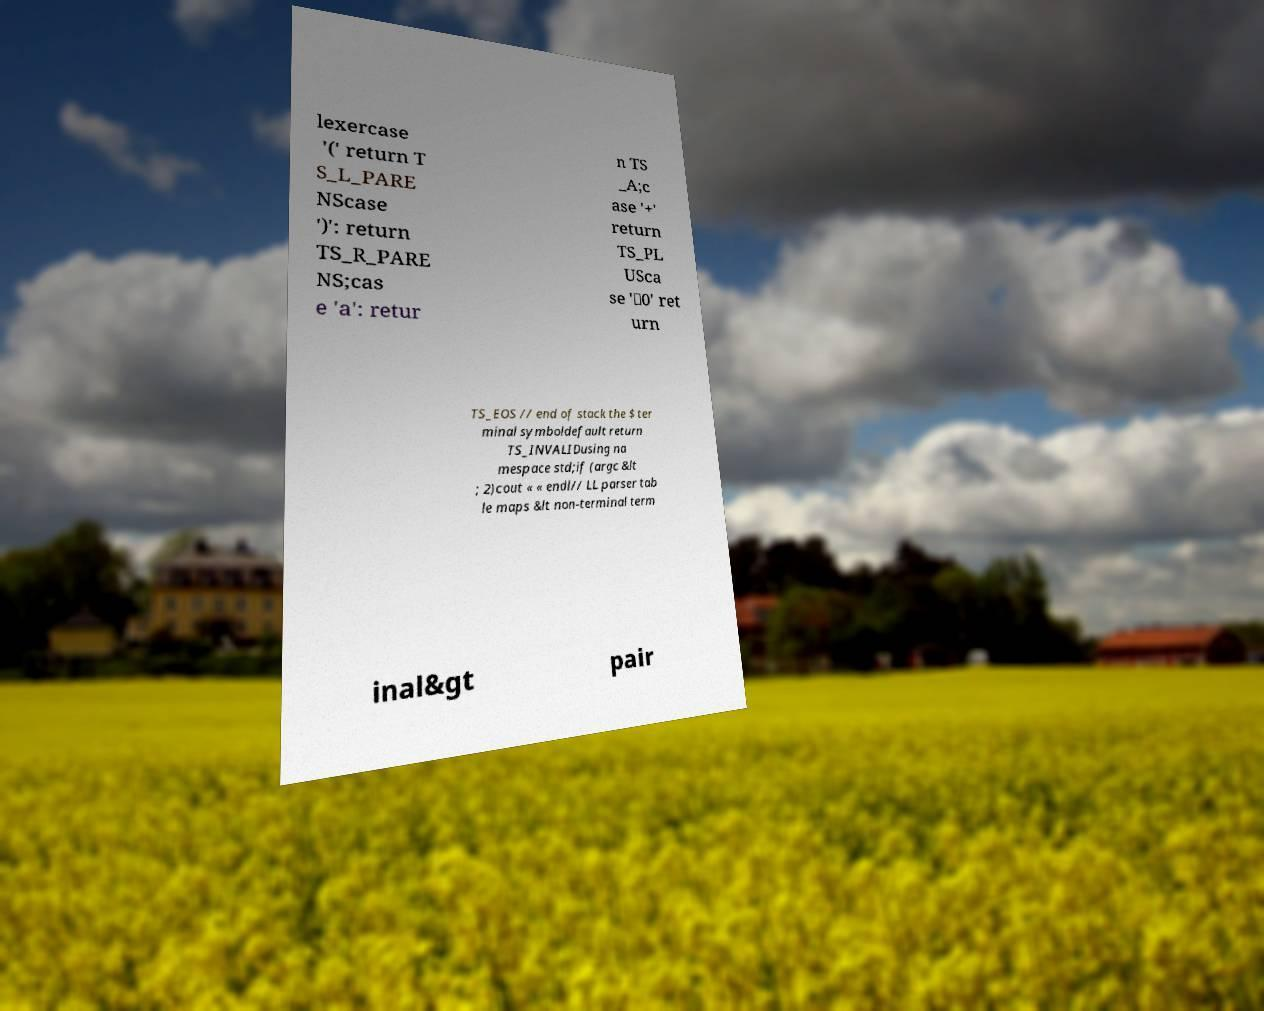Please read and relay the text visible in this image. What does it say? lexercase '(' return T S_L_PARE NScase ')': return TS_R_PARE NS;cas e 'a': retur n TS _A;c ase '+' return TS_PL USca se '\0' ret urn TS_EOS // end of stack the $ ter minal symboldefault return TS_INVALIDusing na mespace std;if (argc &lt ; 2)cout « « endl// LL parser tab le maps &lt non-terminal term inal&gt pair 